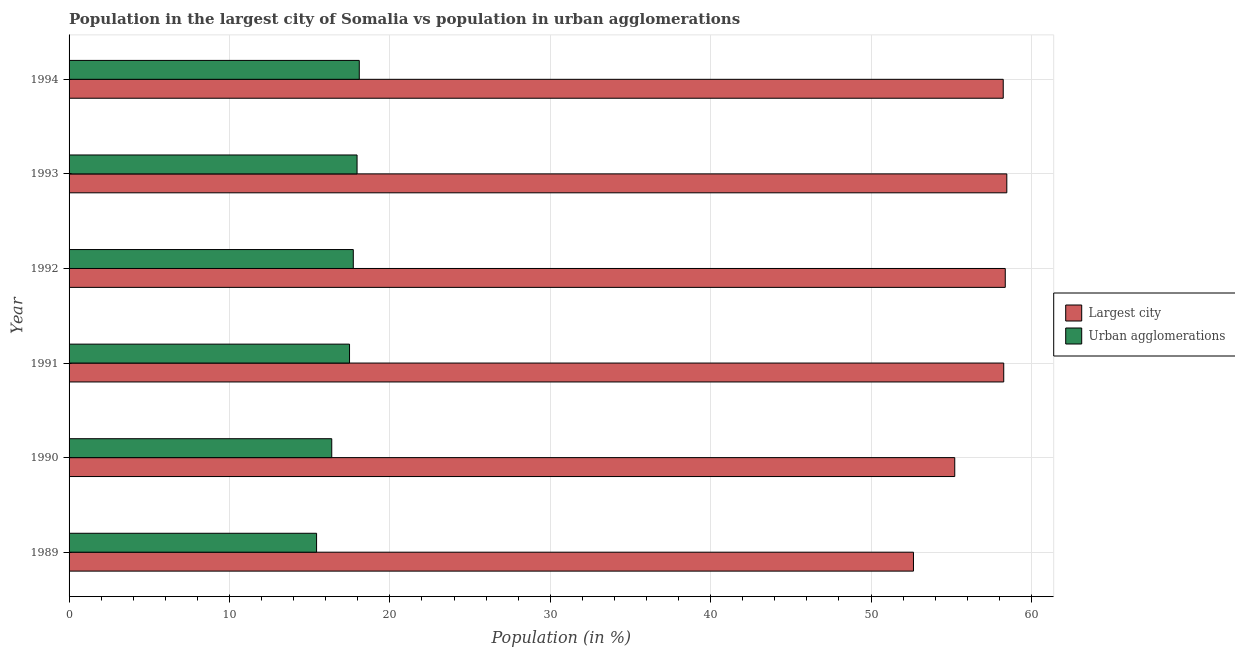How many different coloured bars are there?
Offer a very short reply. 2. Are the number of bars per tick equal to the number of legend labels?
Your answer should be very brief. Yes. How many bars are there on the 3rd tick from the top?
Ensure brevity in your answer.  2. In how many cases, is the number of bars for a given year not equal to the number of legend labels?
Offer a terse response. 0. What is the population in urban agglomerations in 1993?
Ensure brevity in your answer.  17.95. Across all years, what is the maximum population in urban agglomerations?
Offer a terse response. 18.09. Across all years, what is the minimum population in urban agglomerations?
Make the answer very short. 15.43. What is the total population in the largest city in the graph?
Provide a succinct answer. 341.2. What is the difference between the population in urban agglomerations in 1989 and that in 1994?
Provide a short and direct response. -2.66. What is the difference between the population in the largest city in 1992 and the population in urban agglomerations in 1994?
Give a very brief answer. 40.27. What is the average population in the largest city per year?
Offer a terse response. 56.87. In the year 1992, what is the difference between the population in urban agglomerations and population in the largest city?
Provide a succinct answer. -40.65. In how many years, is the population in urban agglomerations greater than 40 %?
Give a very brief answer. 0. What is the ratio of the population in urban agglomerations in 1990 to that in 1994?
Provide a succinct answer. 0.91. Is the population in urban agglomerations in 1990 less than that in 1991?
Your answer should be very brief. Yes. What is the difference between the highest and the second highest population in the largest city?
Ensure brevity in your answer.  0.1. What is the difference between the highest and the lowest population in the largest city?
Give a very brief answer. 5.82. Is the sum of the population in the largest city in 1989 and 1994 greater than the maximum population in urban agglomerations across all years?
Offer a very short reply. Yes. What does the 2nd bar from the top in 1991 represents?
Your answer should be very brief. Largest city. What does the 1st bar from the bottom in 1989 represents?
Your answer should be compact. Largest city. Are all the bars in the graph horizontal?
Offer a very short reply. Yes. How many years are there in the graph?
Provide a succinct answer. 6. What is the difference between two consecutive major ticks on the X-axis?
Your answer should be very brief. 10. Does the graph contain any zero values?
Keep it short and to the point. No. What is the title of the graph?
Provide a succinct answer. Population in the largest city of Somalia vs population in urban agglomerations. Does "Girls" appear as one of the legend labels in the graph?
Keep it short and to the point. No. What is the label or title of the X-axis?
Keep it short and to the point. Population (in %). What is the Population (in %) of Largest city in 1989?
Offer a terse response. 52.64. What is the Population (in %) of Urban agglomerations in 1989?
Offer a very short reply. 15.43. What is the Population (in %) in Largest city in 1990?
Your answer should be compact. 55.22. What is the Population (in %) in Urban agglomerations in 1990?
Give a very brief answer. 16.38. What is the Population (in %) of Largest city in 1991?
Offer a terse response. 58.27. What is the Population (in %) of Urban agglomerations in 1991?
Keep it short and to the point. 17.49. What is the Population (in %) in Largest city in 1992?
Offer a terse response. 58.37. What is the Population (in %) in Urban agglomerations in 1992?
Your response must be concise. 17.72. What is the Population (in %) in Largest city in 1993?
Provide a succinct answer. 58.46. What is the Population (in %) of Urban agglomerations in 1993?
Provide a succinct answer. 17.95. What is the Population (in %) of Largest city in 1994?
Provide a short and direct response. 58.24. What is the Population (in %) of Urban agglomerations in 1994?
Offer a very short reply. 18.09. Across all years, what is the maximum Population (in %) of Largest city?
Provide a short and direct response. 58.46. Across all years, what is the maximum Population (in %) in Urban agglomerations?
Offer a very short reply. 18.09. Across all years, what is the minimum Population (in %) in Largest city?
Provide a succinct answer. 52.64. Across all years, what is the minimum Population (in %) of Urban agglomerations?
Your answer should be very brief. 15.43. What is the total Population (in %) of Largest city in the graph?
Keep it short and to the point. 341.2. What is the total Population (in %) of Urban agglomerations in the graph?
Provide a succinct answer. 103.06. What is the difference between the Population (in %) of Largest city in 1989 and that in 1990?
Provide a succinct answer. -2.57. What is the difference between the Population (in %) in Urban agglomerations in 1989 and that in 1990?
Your answer should be compact. -0.95. What is the difference between the Population (in %) in Largest city in 1989 and that in 1991?
Give a very brief answer. -5.63. What is the difference between the Population (in %) of Urban agglomerations in 1989 and that in 1991?
Offer a very short reply. -2.05. What is the difference between the Population (in %) in Largest city in 1989 and that in 1992?
Provide a short and direct response. -5.72. What is the difference between the Population (in %) of Urban agglomerations in 1989 and that in 1992?
Your answer should be compact. -2.29. What is the difference between the Population (in %) of Largest city in 1989 and that in 1993?
Make the answer very short. -5.82. What is the difference between the Population (in %) of Urban agglomerations in 1989 and that in 1993?
Your answer should be very brief. -2.52. What is the difference between the Population (in %) in Largest city in 1989 and that in 1994?
Give a very brief answer. -5.6. What is the difference between the Population (in %) in Urban agglomerations in 1989 and that in 1994?
Offer a terse response. -2.66. What is the difference between the Population (in %) in Largest city in 1990 and that in 1991?
Make the answer very short. -3.05. What is the difference between the Population (in %) of Urban agglomerations in 1990 and that in 1991?
Provide a succinct answer. -1.11. What is the difference between the Population (in %) of Largest city in 1990 and that in 1992?
Provide a succinct answer. -3.15. What is the difference between the Population (in %) of Urban agglomerations in 1990 and that in 1992?
Keep it short and to the point. -1.34. What is the difference between the Population (in %) of Largest city in 1990 and that in 1993?
Keep it short and to the point. -3.25. What is the difference between the Population (in %) in Urban agglomerations in 1990 and that in 1993?
Offer a terse response. -1.58. What is the difference between the Population (in %) in Largest city in 1990 and that in 1994?
Your answer should be compact. -3.02. What is the difference between the Population (in %) of Urban agglomerations in 1990 and that in 1994?
Ensure brevity in your answer.  -1.72. What is the difference between the Population (in %) in Largest city in 1991 and that in 1992?
Offer a very short reply. -0.1. What is the difference between the Population (in %) of Urban agglomerations in 1991 and that in 1992?
Ensure brevity in your answer.  -0.23. What is the difference between the Population (in %) of Largest city in 1991 and that in 1993?
Ensure brevity in your answer.  -0.19. What is the difference between the Population (in %) of Urban agglomerations in 1991 and that in 1993?
Offer a terse response. -0.47. What is the difference between the Population (in %) of Largest city in 1991 and that in 1994?
Keep it short and to the point. 0.03. What is the difference between the Population (in %) of Urban agglomerations in 1991 and that in 1994?
Offer a terse response. -0.61. What is the difference between the Population (in %) of Largest city in 1992 and that in 1993?
Offer a very short reply. -0.1. What is the difference between the Population (in %) of Urban agglomerations in 1992 and that in 1993?
Provide a short and direct response. -0.23. What is the difference between the Population (in %) in Largest city in 1992 and that in 1994?
Give a very brief answer. 0.13. What is the difference between the Population (in %) of Urban agglomerations in 1992 and that in 1994?
Make the answer very short. -0.37. What is the difference between the Population (in %) in Largest city in 1993 and that in 1994?
Provide a succinct answer. 0.22. What is the difference between the Population (in %) in Urban agglomerations in 1993 and that in 1994?
Your answer should be very brief. -0.14. What is the difference between the Population (in %) of Largest city in 1989 and the Population (in %) of Urban agglomerations in 1990?
Ensure brevity in your answer.  36.27. What is the difference between the Population (in %) in Largest city in 1989 and the Population (in %) in Urban agglomerations in 1991?
Make the answer very short. 35.16. What is the difference between the Population (in %) in Largest city in 1989 and the Population (in %) in Urban agglomerations in 1992?
Offer a very short reply. 34.92. What is the difference between the Population (in %) in Largest city in 1989 and the Population (in %) in Urban agglomerations in 1993?
Ensure brevity in your answer.  34.69. What is the difference between the Population (in %) of Largest city in 1989 and the Population (in %) of Urban agglomerations in 1994?
Give a very brief answer. 34.55. What is the difference between the Population (in %) in Largest city in 1990 and the Population (in %) in Urban agglomerations in 1991?
Ensure brevity in your answer.  37.73. What is the difference between the Population (in %) in Largest city in 1990 and the Population (in %) in Urban agglomerations in 1992?
Make the answer very short. 37.5. What is the difference between the Population (in %) in Largest city in 1990 and the Population (in %) in Urban agglomerations in 1993?
Your answer should be very brief. 37.26. What is the difference between the Population (in %) in Largest city in 1990 and the Population (in %) in Urban agglomerations in 1994?
Make the answer very short. 37.12. What is the difference between the Population (in %) in Largest city in 1991 and the Population (in %) in Urban agglomerations in 1992?
Your response must be concise. 40.55. What is the difference between the Population (in %) in Largest city in 1991 and the Population (in %) in Urban agglomerations in 1993?
Your answer should be very brief. 40.32. What is the difference between the Population (in %) of Largest city in 1991 and the Population (in %) of Urban agglomerations in 1994?
Provide a short and direct response. 40.18. What is the difference between the Population (in %) in Largest city in 1992 and the Population (in %) in Urban agglomerations in 1993?
Give a very brief answer. 40.41. What is the difference between the Population (in %) of Largest city in 1992 and the Population (in %) of Urban agglomerations in 1994?
Make the answer very short. 40.27. What is the difference between the Population (in %) of Largest city in 1993 and the Population (in %) of Urban agglomerations in 1994?
Provide a short and direct response. 40.37. What is the average Population (in %) of Largest city per year?
Your response must be concise. 56.87. What is the average Population (in %) in Urban agglomerations per year?
Provide a succinct answer. 17.18. In the year 1989, what is the difference between the Population (in %) in Largest city and Population (in %) in Urban agglomerations?
Offer a very short reply. 37.21. In the year 1990, what is the difference between the Population (in %) of Largest city and Population (in %) of Urban agglomerations?
Your response must be concise. 38.84. In the year 1991, what is the difference between the Population (in %) in Largest city and Population (in %) in Urban agglomerations?
Ensure brevity in your answer.  40.79. In the year 1992, what is the difference between the Population (in %) in Largest city and Population (in %) in Urban agglomerations?
Offer a terse response. 40.65. In the year 1993, what is the difference between the Population (in %) of Largest city and Population (in %) of Urban agglomerations?
Your response must be concise. 40.51. In the year 1994, what is the difference between the Population (in %) in Largest city and Population (in %) in Urban agglomerations?
Offer a very short reply. 40.15. What is the ratio of the Population (in %) in Largest city in 1989 to that in 1990?
Your answer should be compact. 0.95. What is the ratio of the Population (in %) of Urban agglomerations in 1989 to that in 1990?
Your answer should be compact. 0.94. What is the ratio of the Population (in %) in Largest city in 1989 to that in 1991?
Offer a terse response. 0.9. What is the ratio of the Population (in %) in Urban agglomerations in 1989 to that in 1991?
Provide a short and direct response. 0.88. What is the ratio of the Population (in %) of Largest city in 1989 to that in 1992?
Your answer should be compact. 0.9. What is the ratio of the Population (in %) in Urban agglomerations in 1989 to that in 1992?
Make the answer very short. 0.87. What is the ratio of the Population (in %) in Largest city in 1989 to that in 1993?
Provide a succinct answer. 0.9. What is the ratio of the Population (in %) of Urban agglomerations in 1989 to that in 1993?
Give a very brief answer. 0.86. What is the ratio of the Population (in %) of Largest city in 1989 to that in 1994?
Offer a very short reply. 0.9. What is the ratio of the Population (in %) in Urban agglomerations in 1989 to that in 1994?
Offer a very short reply. 0.85. What is the ratio of the Population (in %) of Largest city in 1990 to that in 1991?
Offer a terse response. 0.95. What is the ratio of the Population (in %) of Urban agglomerations in 1990 to that in 1991?
Your response must be concise. 0.94. What is the ratio of the Population (in %) in Largest city in 1990 to that in 1992?
Make the answer very short. 0.95. What is the ratio of the Population (in %) of Urban agglomerations in 1990 to that in 1992?
Your response must be concise. 0.92. What is the ratio of the Population (in %) in Largest city in 1990 to that in 1993?
Give a very brief answer. 0.94. What is the ratio of the Population (in %) of Urban agglomerations in 1990 to that in 1993?
Your response must be concise. 0.91. What is the ratio of the Population (in %) in Largest city in 1990 to that in 1994?
Offer a terse response. 0.95. What is the ratio of the Population (in %) of Urban agglomerations in 1990 to that in 1994?
Ensure brevity in your answer.  0.91. What is the ratio of the Population (in %) in Largest city in 1991 to that in 1992?
Offer a very short reply. 1. What is the ratio of the Population (in %) of Urban agglomerations in 1991 to that in 1992?
Your answer should be compact. 0.99. What is the ratio of the Population (in %) of Largest city in 1991 to that in 1993?
Offer a very short reply. 1. What is the ratio of the Population (in %) of Urban agglomerations in 1991 to that in 1993?
Your answer should be very brief. 0.97. What is the ratio of the Population (in %) in Urban agglomerations in 1991 to that in 1994?
Your response must be concise. 0.97. What is the ratio of the Population (in %) in Urban agglomerations in 1992 to that in 1993?
Provide a succinct answer. 0.99. What is the ratio of the Population (in %) of Largest city in 1992 to that in 1994?
Give a very brief answer. 1. What is the ratio of the Population (in %) of Urban agglomerations in 1992 to that in 1994?
Make the answer very short. 0.98. What is the ratio of the Population (in %) of Largest city in 1993 to that in 1994?
Provide a succinct answer. 1. What is the difference between the highest and the second highest Population (in %) in Largest city?
Your response must be concise. 0.1. What is the difference between the highest and the second highest Population (in %) in Urban agglomerations?
Keep it short and to the point. 0.14. What is the difference between the highest and the lowest Population (in %) in Largest city?
Your answer should be very brief. 5.82. What is the difference between the highest and the lowest Population (in %) in Urban agglomerations?
Make the answer very short. 2.66. 